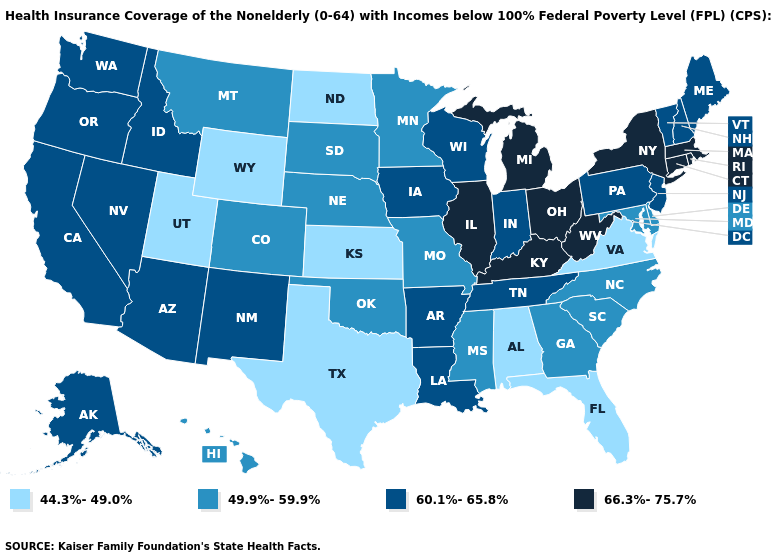What is the value of Iowa?
Quick response, please. 60.1%-65.8%. What is the value of Wisconsin?
Give a very brief answer. 60.1%-65.8%. Among the states that border Idaho , which have the highest value?
Keep it brief. Nevada, Oregon, Washington. What is the highest value in states that border Montana?
Answer briefly. 60.1%-65.8%. Name the states that have a value in the range 44.3%-49.0%?
Write a very short answer. Alabama, Florida, Kansas, North Dakota, Texas, Utah, Virginia, Wyoming. Does Rhode Island have a higher value than New York?
Keep it brief. No. What is the value of Idaho?
Short answer required. 60.1%-65.8%. What is the highest value in the South ?
Keep it brief. 66.3%-75.7%. How many symbols are there in the legend?
Quick response, please. 4. Name the states that have a value in the range 49.9%-59.9%?
Answer briefly. Colorado, Delaware, Georgia, Hawaii, Maryland, Minnesota, Mississippi, Missouri, Montana, Nebraska, North Carolina, Oklahoma, South Carolina, South Dakota. What is the value of Rhode Island?
Quick response, please. 66.3%-75.7%. Does Missouri have the highest value in the MidWest?
Short answer required. No. What is the lowest value in the South?
Answer briefly. 44.3%-49.0%. What is the lowest value in the USA?
Concise answer only. 44.3%-49.0%. Does Iowa have the highest value in the MidWest?
Give a very brief answer. No. 